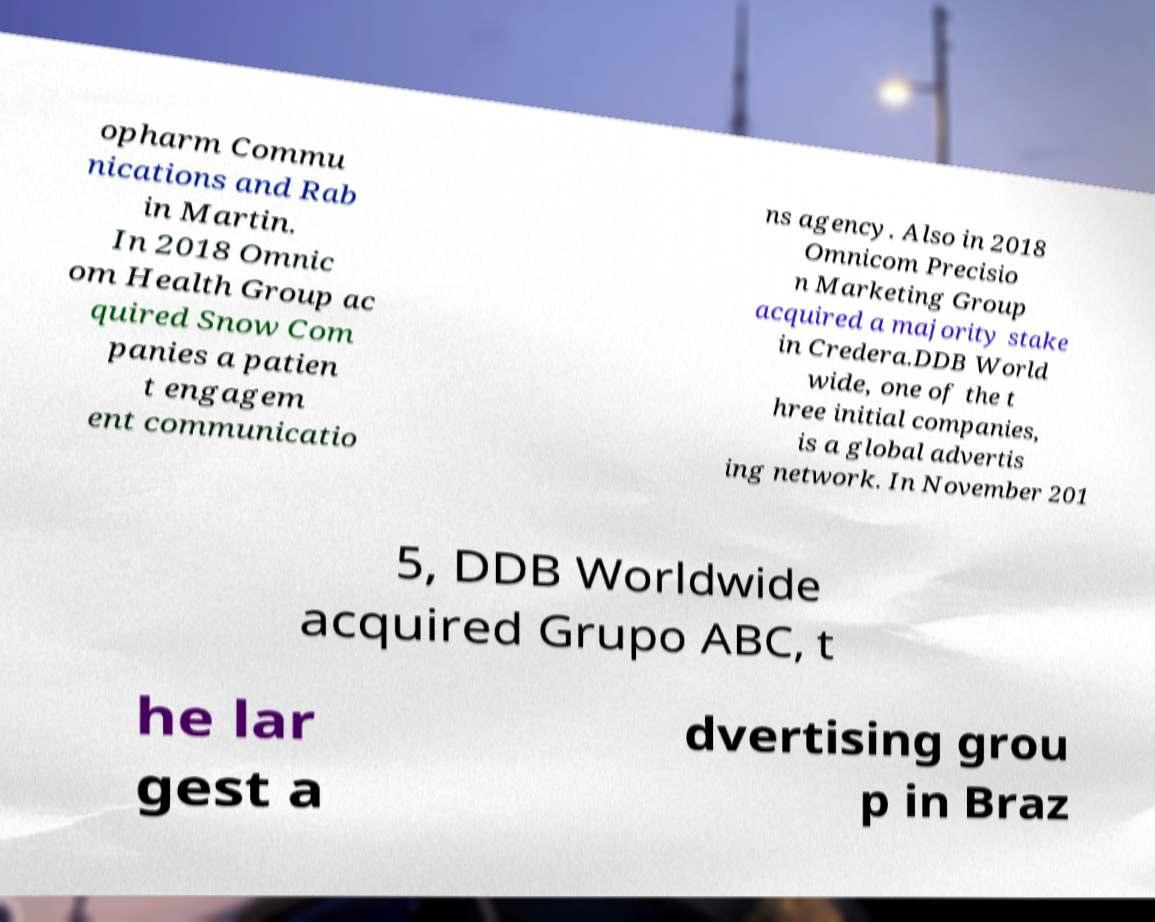Can you accurately transcribe the text from the provided image for me? opharm Commu nications and Rab in Martin. In 2018 Omnic om Health Group ac quired Snow Com panies a patien t engagem ent communicatio ns agency. Also in 2018 Omnicom Precisio n Marketing Group acquired a majority stake in Credera.DDB World wide, one of the t hree initial companies, is a global advertis ing network. In November 201 5, DDB Worldwide acquired Grupo ABC, t he lar gest a dvertising grou p in Braz 